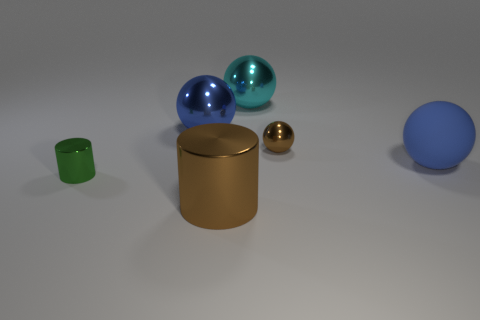How many blue balls must be subtracted to get 1 blue balls? 1 Add 1 rubber balls. How many objects exist? 7 Subtract all green cylinders. How many cylinders are left? 1 Subtract all small spheres. How many spheres are left? 3 Subtract 0 purple spheres. How many objects are left? 6 Subtract all cylinders. How many objects are left? 4 Subtract 3 balls. How many balls are left? 1 Subtract all blue balls. Subtract all gray blocks. How many balls are left? 2 Subtract all brown cylinders. How many brown spheres are left? 1 Subtract all big matte spheres. Subtract all small gray matte cylinders. How many objects are left? 5 